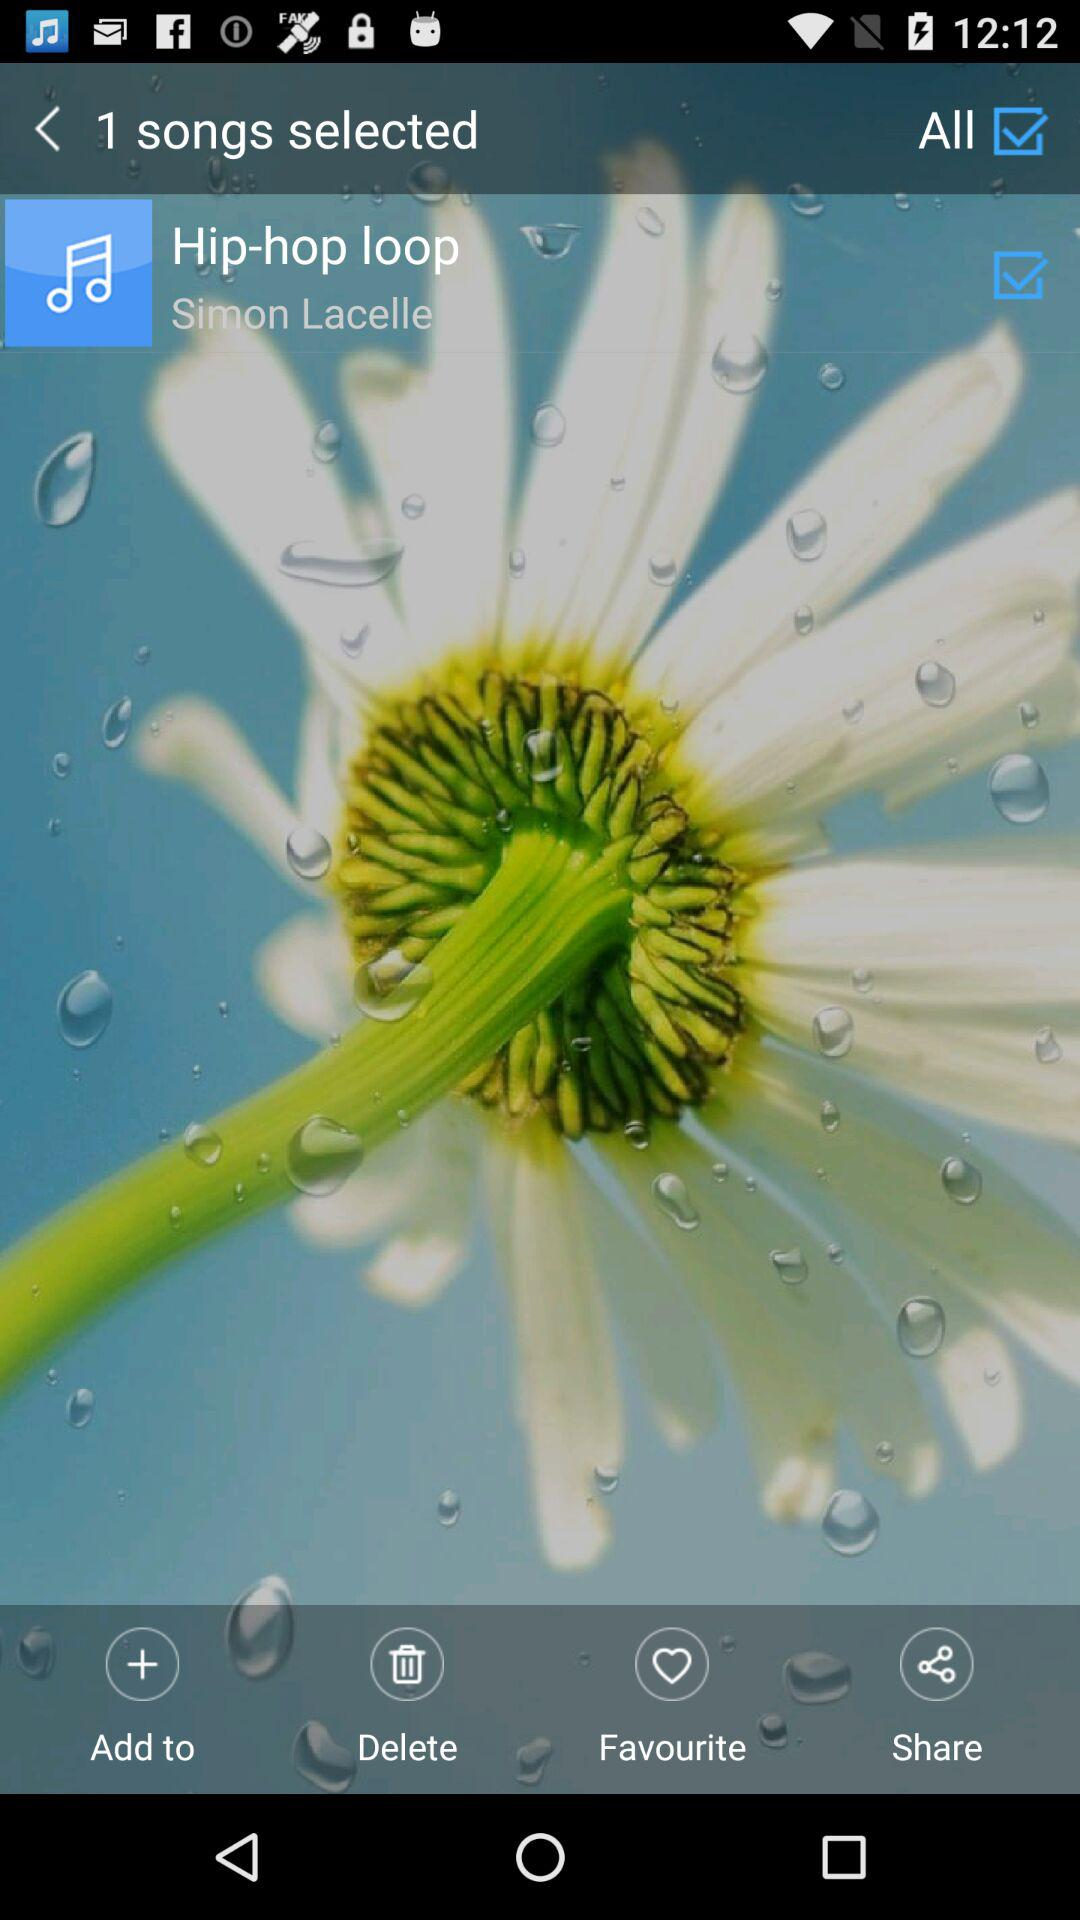Which song has been selected? The selected song is "Hip-hop loop". 